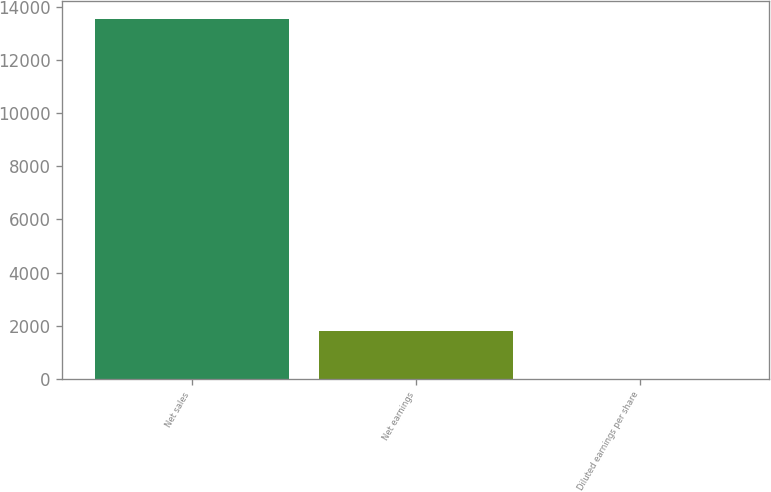Convert chart. <chart><loc_0><loc_0><loc_500><loc_500><bar_chart><fcel>Net sales<fcel>Net earnings<fcel>Diluted earnings per share<nl><fcel>13546.8<fcel>1806.1<fcel>2.66<nl></chart> 